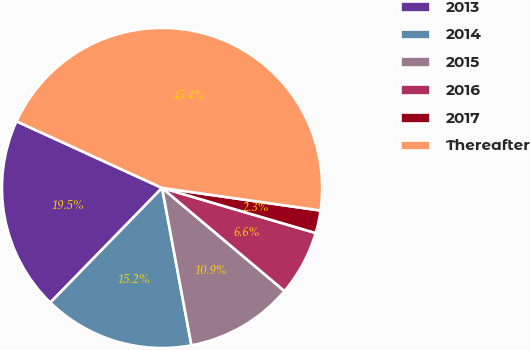<chart> <loc_0><loc_0><loc_500><loc_500><pie_chart><fcel>2013<fcel>2014<fcel>2015<fcel>2016<fcel>2017<fcel>Thereafter<nl><fcel>19.54%<fcel>15.23%<fcel>10.92%<fcel>6.6%<fcel>2.29%<fcel>45.42%<nl></chart> 